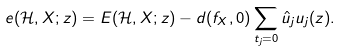<formula> <loc_0><loc_0><loc_500><loc_500>e ( \mathcal { H } , X ; z ) = E ( \mathcal { H } , X ; z ) - d ( f _ { X } , 0 ) \sum _ { t _ { j } = 0 } \hat { u } _ { j } u _ { j } ( z ) .</formula> 